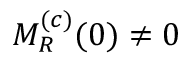<formula> <loc_0><loc_0><loc_500><loc_500>M _ { R } ^ { ( c ) } ( 0 ) \neq 0</formula> 